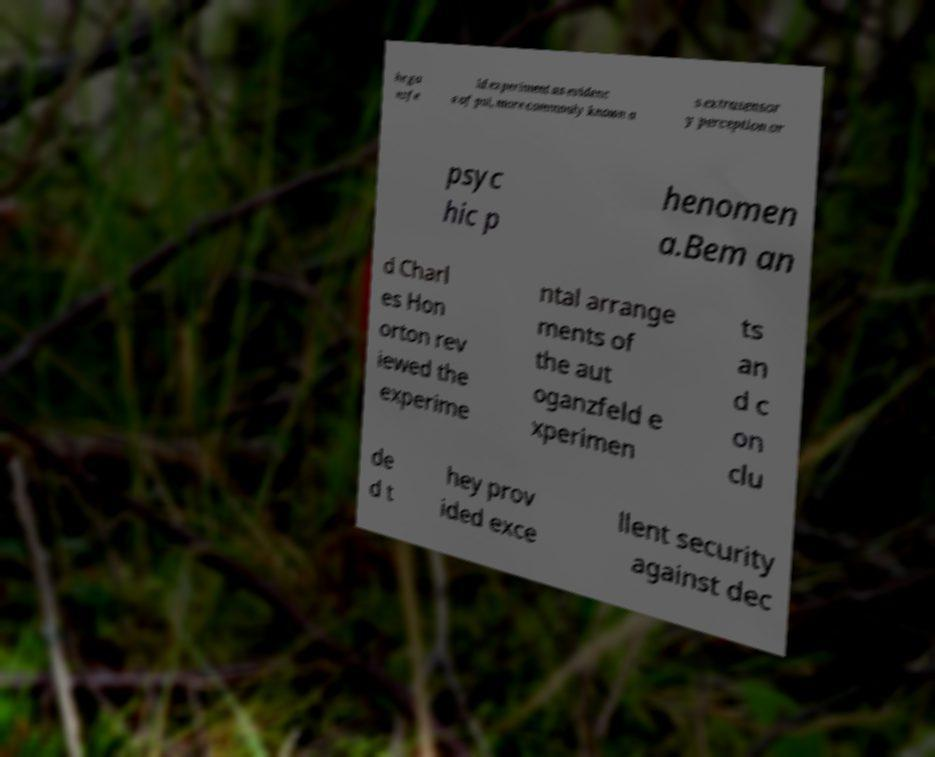Please identify and transcribe the text found in this image. he ga nzfe ld experiment as evidenc e of psi, more commonly known a s extrasensor y perception or psyc hic p henomen a.Bem an d Charl es Hon orton rev iewed the experime ntal arrange ments of the aut oganzfeld e xperimen ts an d c on clu de d t hey prov ided exce llent security against dec 